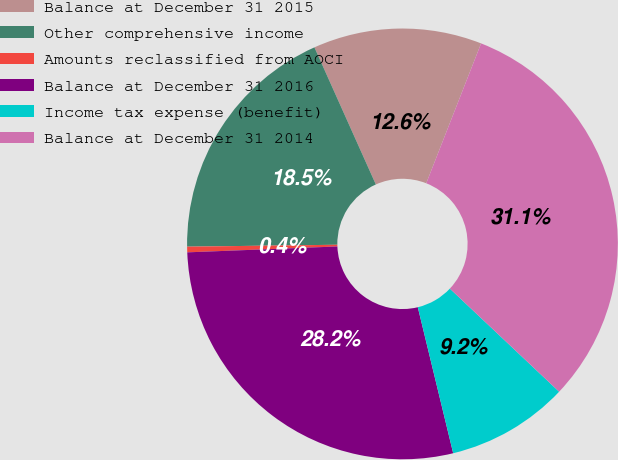<chart> <loc_0><loc_0><loc_500><loc_500><pie_chart><fcel>Balance at December 31 2015<fcel>Other comprehensive income<fcel>Amounts reclassified from AOCI<fcel>Balance at December 31 2016<fcel>Income tax expense (benefit)<fcel>Balance at December 31 2014<nl><fcel>12.65%<fcel>18.5%<fcel>0.42%<fcel>28.16%<fcel>9.18%<fcel>31.09%<nl></chart> 